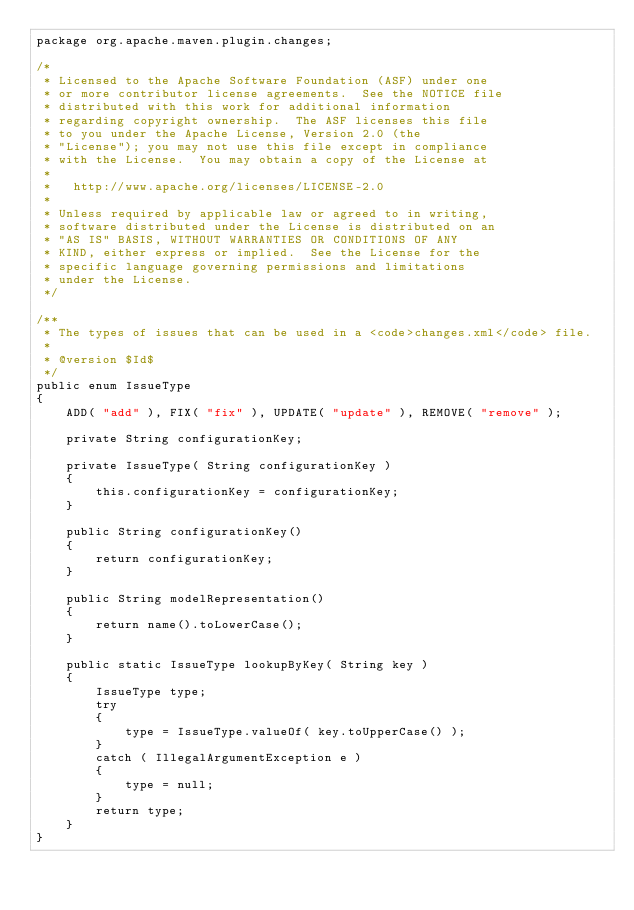<code> <loc_0><loc_0><loc_500><loc_500><_Java_>package org.apache.maven.plugin.changes;

/*
 * Licensed to the Apache Software Foundation (ASF) under one
 * or more contributor license agreements.  See the NOTICE file
 * distributed with this work for additional information
 * regarding copyright ownership.  The ASF licenses this file
 * to you under the Apache License, Version 2.0 (the
 * "License"); you may not use this file except in compliance
 * with the License.  You may obtain a copy of the License at
 *
 *   http://www.apache.org/licenses/LICENSE-2.0
 *
 * Unless required by applicable law or agreed to in writing,
 * software distributed under the License is distributed on an
 * "AS IS" BASIS, WITHOUT WARRANTIES OR CONDITIONS OF ANY
 * KIND, either express or implied.  See the License for the
 * specific language governing permissions and limitations
 * under the License.
 */

/**
 * The types of issues that can be used in a <code>changes.xml</code> file.
 *
 * @version $Id$
 */
public enum IssueType
{
    ADD( "add" ), FIX( "fix" ), UPDATE( "update" ), REMOVE( "remove" );

    private String configurationKey;

    private IssueType( String configurationKey )
    {
        this.configurationKey = configurationKey;
    }

    public String configurationKey()
    {
        return configurationKey;
    }

    public String modelRepresentation()
    {
        return name().toLowerCase();
    }

    public static IssueType lookupByKey( String key )
    {
        IssueType type;
        try
        {
            type = IssueType.valueOf( key.toUpperCase() );
        }
        catch ( IllegalArgumentException e )
        {
            type = null;
        }
        return type;
    }
}
</code> 